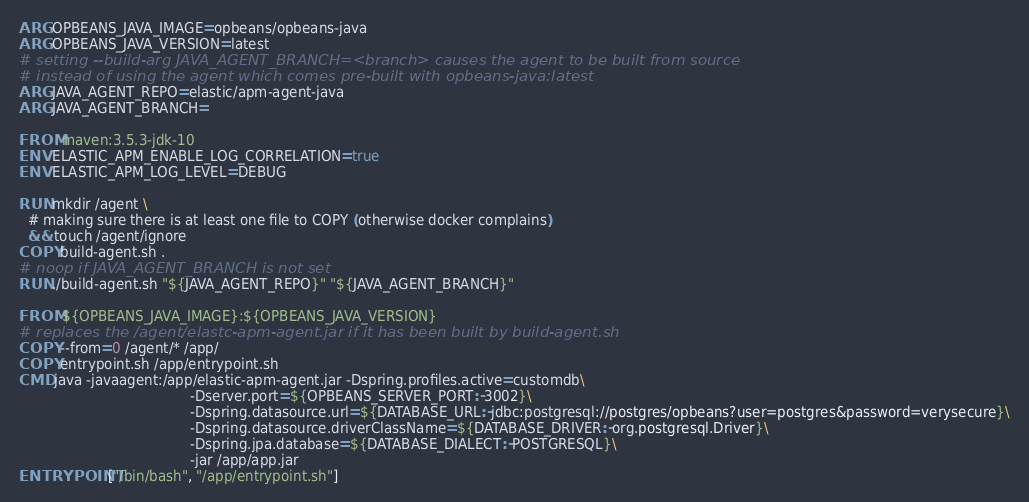Convert code to text. <code><loc_0><loc_0><loc_500><loc_500><_Dockerfile_>ARG OPBEANS_JAVA_IMAGE=opbeans/opbeans-java
ARG OPBEANS_JAVA_VERSION=latest
# setting --build-arg JAVA_AGENT_BRANCH=<branch> causes the agent to be built from source
# instead of using the agent which comes pre-built with opbeans-java:latest
ARG JAVA_AGENT_REPO=elastic/apm-agent-java
ARG JAVA_AGENT_BRANCH=

FROM maven:3.5.3-jdk-10
ENV ELASTIC_APM_ENABLE_LOG_CORRELATION=true
ENV ELASTIC_APM_LOG_LEVEL=DEBUG

RUN mkdir /agent \
  # making sure there is at least one file to COPY (otherwise docker complains)
  && touch /agent/ignore
COPY build-agent.sh .
# noop if JAVA_AGENT_BRANCH is not set
RUN ./build-agent.sh "${JAVA_AGENT_REPO}" "${JAVA_AGENT_BRANCH}"

FROM ${OPBEANS_JAVA_IMAGE}:${OPBEANS_JAVA_VERSION}
# replaces the /agent/elastc-apm-agent.jar if it has been built by build-agent.sh
COPY --from=0 /agent/* /app/
COPY entrypoint.sh /app/entrypoint.sh
CMD java -javaagent:/app/elastic-apm-agent.jar -Dspring.profiles.active=customdb\
                                        -Dserver.port=${OPBEANS_SERVER_PORT:-3002}\
                                        -Dspring.datasource.url=${DATABASE_URL:-jdbc:postgresql://postgres/opbeans?user=postgres&password=verysecure}\
                                        -Dspring.datasource.driverClassName=${DATABASE_DRIVER:-org.postgresql.Driver}\
                                        -Dspring.jpa.database=${DATABASE_DIALECT:-POSTGRESQL}\
                                        -jar /app/app.jar
ENTRYPOINT ["/bin/bash", "/app/entrypoint.sh"]
</code> 